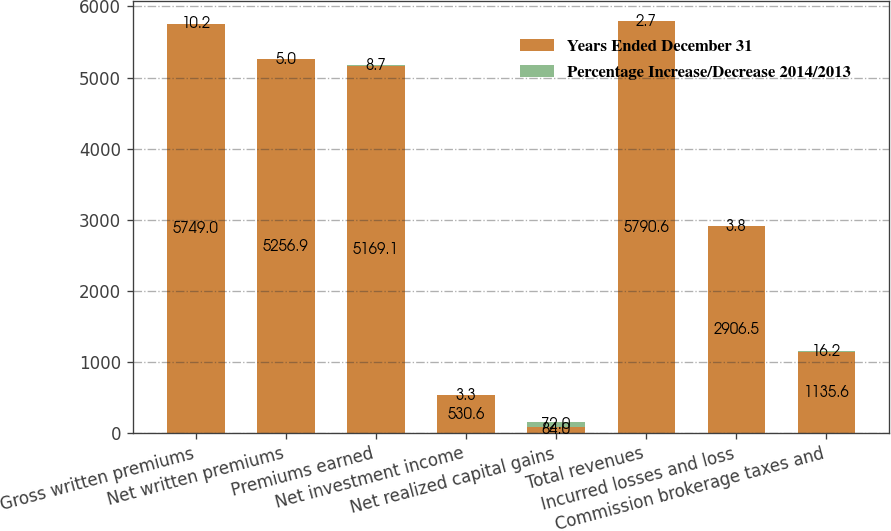Convert chart. <chart><loc_0><loc_0><loc_500><loc_500><stacked_bar_chart><ecel><fcel>Gross written premiums<fcel>Net written premiums<fcel>Premiums earned<fcel>Net investment income<fcel>Net realized capital gains<fcel>Total revenues<fcel>Incurred losses and loss<fcel>Commission brokerage taxes and<nl><fcel>Years Ended December 31<fcel>5749<fcel>5256.9<fcel>5169.1<fcel>530.6<fcel>84<fcel>5790.6<fcel>2906.5<fcel>1135.6<nl><fcel>Percentage Increase/Decrease 2014/2013<fcel>10.2<fcel>5<fcel>8.7<fcel>3.3<fcel>72<fcel>2.7<fcel>3.8<fcel>16.2<nl></chart> 